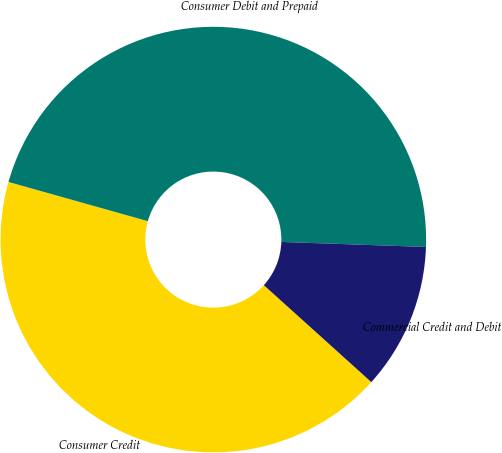Convert chart. <chart><loc_0><loc_0><loc_500><loc_500><pie_chart><fcel>Consumer Credit<fcel>Consumer Debit and Prepaid<fcel>Commercial Credit and Debit<nl><fcel>42.69%<fcel>46.19%<fcel>11.13%<nl></chart> 